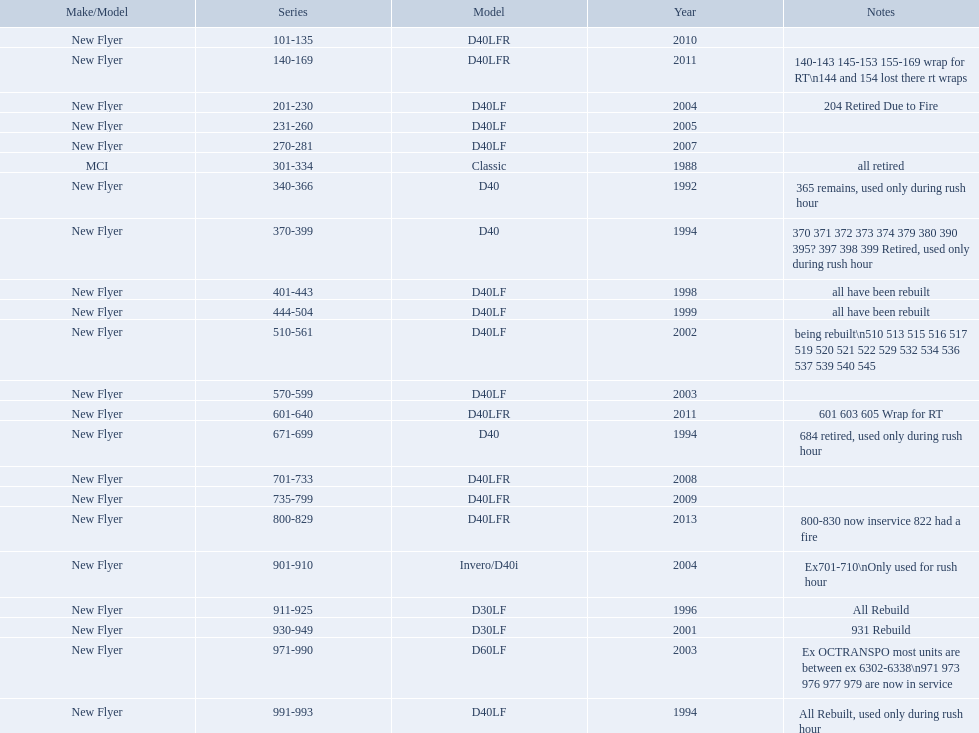What are all of the bus series numbers? 101-135, 140-169, 201-230, 231-260, 270-281, 301-334, 340-366, 370-399, 401-443, 444-504, 510-561, 570-599, 601-640, 671-699, 701-733, 735-799, 800-829, 901-910, 911-925, 930-949, 971-990, 991-993. When were they introduced? 2010, 2011, 2004, 2005, 2007, 1988, 1992, 1994, 1998, 1999, 2002, 2003, 2011, 1994, 2008, 2009, 2013, 2004, 1996, 2001, 2003, 1994. Which series is the newest? 800-829. What are the total bus series numbers? 101-135, 140-169, 201-230, 231-260, 270-281, 301-334, 340-366, 370-399, 401-443, 444-504, 510-561, 570-599, 601-640, 671-699, 701-733, 735-799, 800-829, 901-910, 911-925, 930-949, 971-990, 991-993. When were they presented? 2010, 2011, 2004, 2005, 2007, 1988, 1992, 1994, 1998, 1999, 2002, 2003, 2011, 1994, 2008, 2009, 2013, 2004, 1996, 2001, 2003, 1994. Which series is the newest? 800-829. What are the complete lineup of bus series? 101-135, 140-169, 201-230, 231-260, 270-281, 301-334, 340-366, 370-399, 401-443, 444-504, 510-561, 570-599, 601-640, 671-699, 701-733, 735-799, 800-829, 901-910, 911-925, 930-949, 971-990, 991-993. Which are the latest? 800-829. What are the complete bus series numbers? 101-135, 140-169, 201-230, 231-260, 270-281, 301-334, 340-366, 370-399, 401-443, 444-504, 510-561, 570-599, 601-640, 671-699, 701-733, 735-799, 800-829, 901-910, 911-925, 930-949, 971-990, 991-993. When did they debut? 2010, 2011, 2004, 2005, 2007, 1988, 1992, 1994, 1998, 1999, 2002, 2003, 2011, 1994, 2008, 2009, 2013, 2004, 1996, 2001, 2003, 1994. Which series is the most recent? 800-829. 